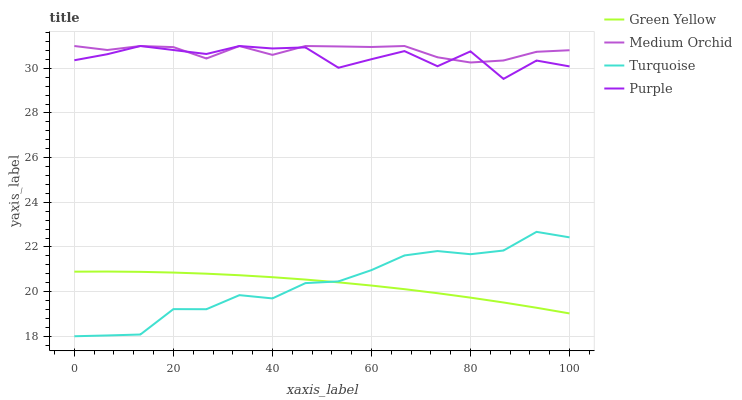Does Medium Orchid have the minimum area under the curve?
Answer yes or no. No. Does Green Yellow have the maximum area under the curve?
Answer yes or no. No. Is Medium Orchid the smoothest?
Answer yes or no. No. Is Medium Orchid the roughest?
Answer yes or no. No. Does Green Yellow have the lowest value?
Answer yes or no. No. Does Green Yellow have the highest value?
Answer yes or no. No. Is Turquoise less than Purple?
Answer yes or no. Yes. Is Purple greater than Turquoise?
Answer yes or no. Yes. Does Turquoise intersect Purple?
Answer yes or no. No. 